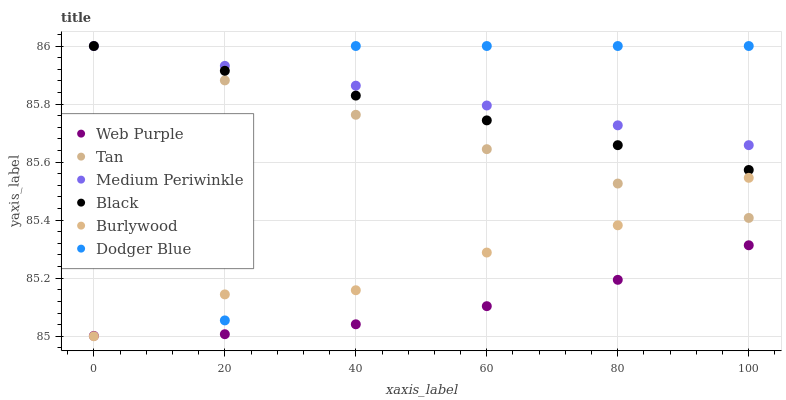Does Web Purple have the minimum area under the curve?
Answer yes or no. Yes. Does Medium Periwinkle have the maximum area under the curve?
Answer yes or no. Yes. Does Medium Periwinkle have the minimum area under the curve?
Answer yes or no. No. Does Web Purple have the maximum area under the curve?
Answer yes or no. No. Is Tan the smoothest?
Answer yes or no. Yes. Is Dodger Blue the roughest?
Answer yes or no. Yes. Is Medium Periwinkle the smoothest?
Answer yes or no. No. Is Medium Periwinkle the roughest?
Answer yes or no. No. Does Burlywood have the lowest value?
Answer yes or no. Yes. Does Web Purple have the lowest value?
Answer yes or no. No. Does Tan have the highest value?
Answer yes or no. Yes. Does Web Purple have the highest value?
Answer yes or no. No. Is Burlywood less than Medium Periwinkle?
Answer yes or no. Yes. Is Dodger Blue greater than Web Purple?
Answer yes or no. Yes. Does Dodger Blue intersect Burlywood?
Answer yes or no. Yes. Is Dodger Blue less than Burlywood?
Answer yes or no. No. Is Dodger Blue greater than Burlywood?
Answer yes or no. No. Does Burlywood intersect Medium Periwinkle?
Answer yes or no. No. 